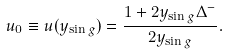Convert formula to latex. <formula><loc_0><loc_0><loc_500><loc_500>u _ { 0 } \equiv u ( y _ { \sin g } ) = \frac { 1 + 2 y _ { \sin g } \Delta ^ { - } } { 2 y _ { \sin g } } .</formula> 